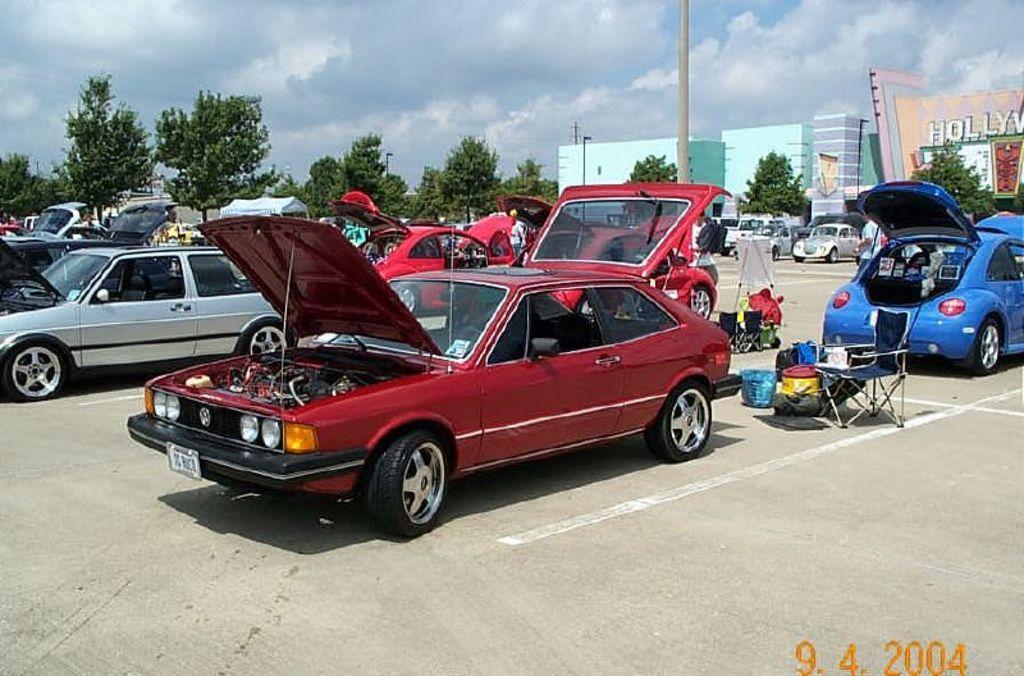Could you give a brief overview of what you see in this image? In the center of the image we can see some vehicles, bags, trolley, poles. In the background of the image we can see some trees, buildings, electric light pole. At the top of the image clouds are present in the sky. At the bottom of the image there is a road. 